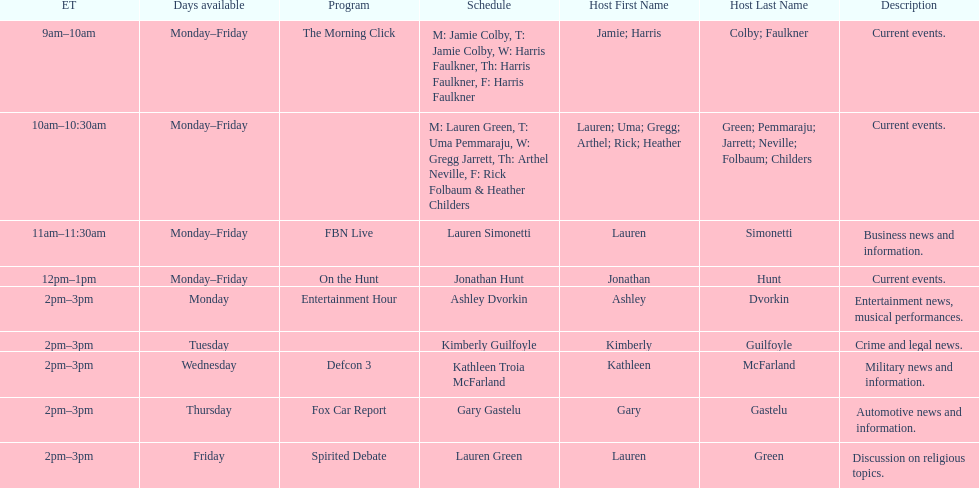How long does the show defcon 3 last? 1 hour. 